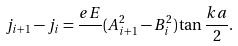Convert formula to latex. <formula><loc_0><loc_0><loc_500><loc_500>j _ { i + 1 } - j _ { i } = \frac { e E } { } ( A _ { i + 1 } ^ { 2 } - B _ { i } ^ { 2 } ) \tan \frac { k a } { 2 } .</formula> 